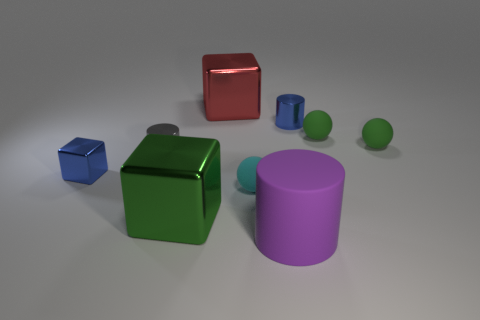Subtract all blocks. How many objects are left? 6 Add 2 cyan matte objects. How many cyan matte objects exist? 3 Subtract 1 green blocks. How many objects are left? 8 Subtract all blue spheres. Subtract all large green metallic blocks. How many objects are left? 8 Add 8 tiny blue cylinders. How many tiny blue cylinders are left? 9 